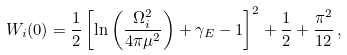<formula> <loc_0><loc_0><loc_500><loc_500>W _ { i } ( 0 ) = \frac { 1 } { 2 } \left [ \ln \left ( \frac { \Omega _ { i } ^ { 2 } } { 4 \pi \mu ^ { 2 } } \right ) + \gamma _ { E } - 1 \right ] ^ { 2 } + \frac { 1 } { 2 } + \frac { \pi ^ { 2 } } { 1 2 } \, ,</formula> 